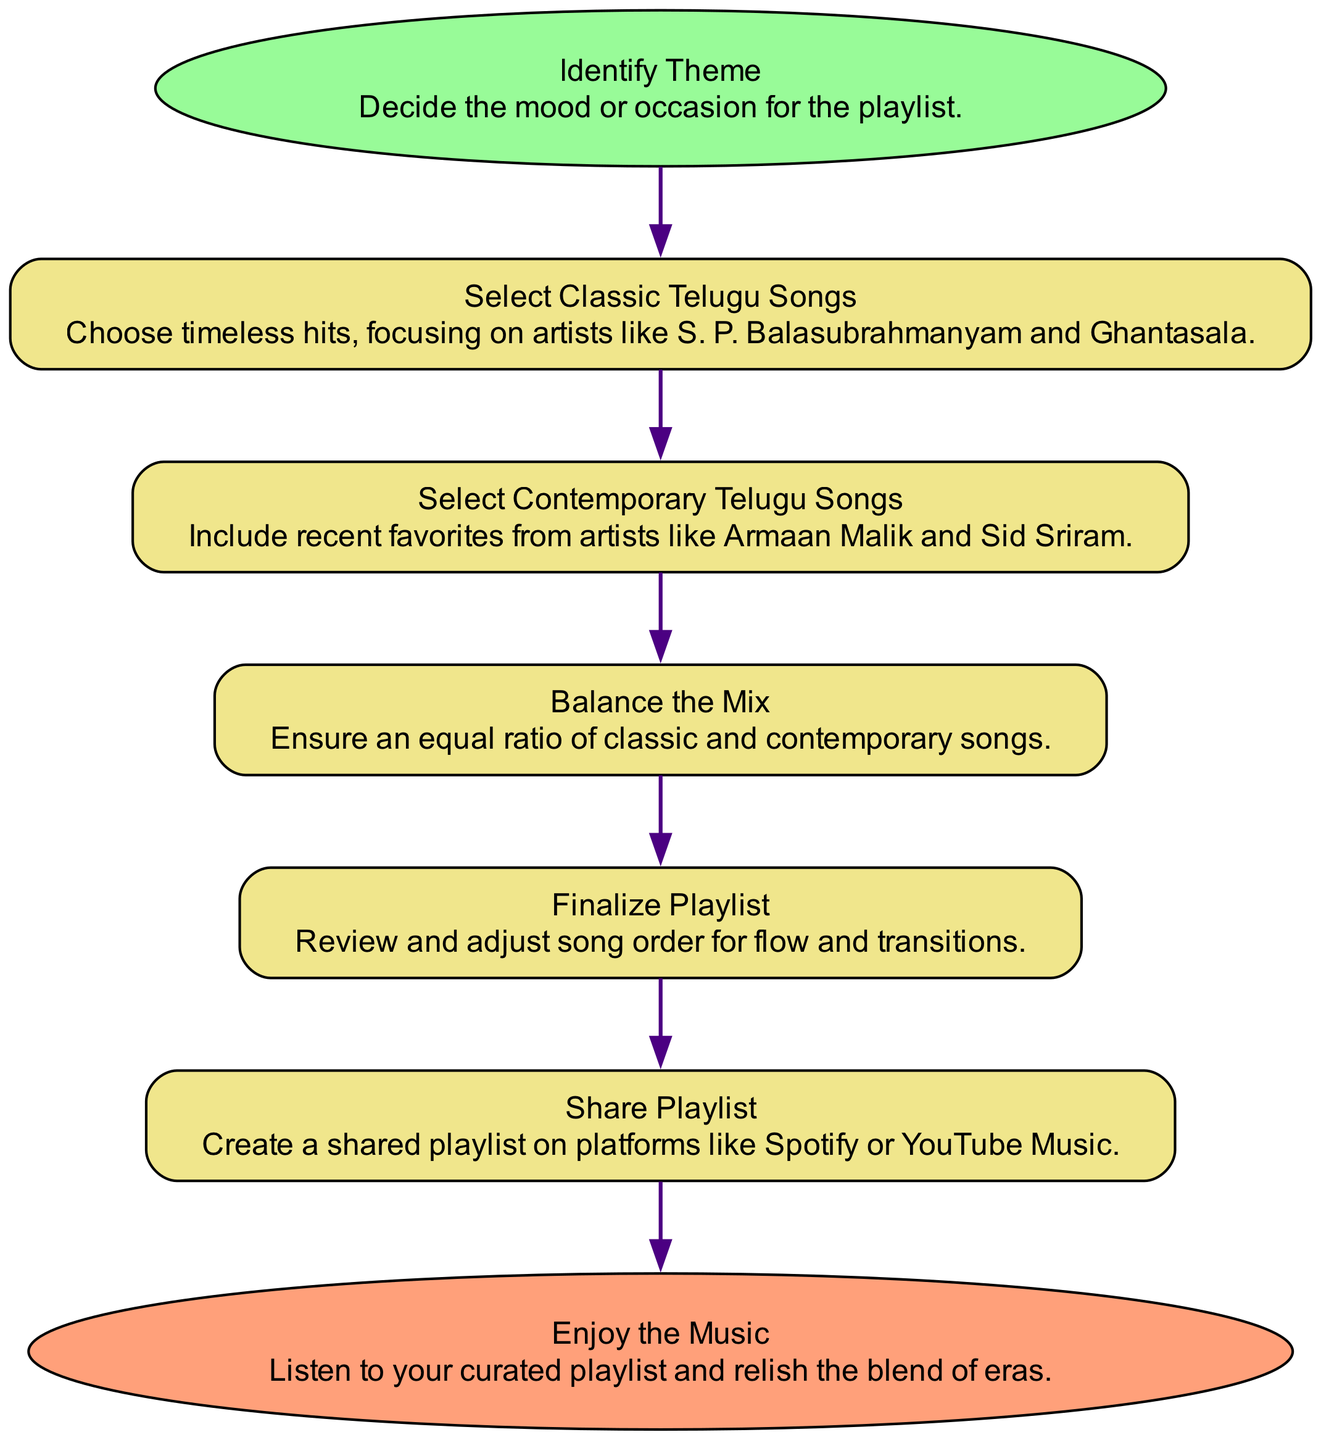What is the first step in the flow chart? The first node in the diagram is labeled "Identify Theme," which is the starting point for creating the playlist.
Answer: Identify Theme Which artist is mentioned in the classic selection step? The classic selection step specifically highlights artists like S. P. Balasubrahmanyam and Ghantasala as examples of timeless hits to include.
Answer: S. P. Balasubrahmanyam What is the purpose of the "Balance the Mix" step? This step ensures that the playlist contains an equal ratio of classic and contemporary songs, maintaining a balanced listening experience.
Answer: Ensure an equal ratio How many nodes are there in the flow chart? Counting each unique step including start and end nodes, there are a total of six nodes in the flow chart.
Answer: Six What comes after "Select Classic Telugu Songs"? The next step in the flow chart after "Select Classic Telugu Songs" is "Select Contemporary Telugu Songs," indicating a progression in creating the playlist.
Answer: Select Contemporary Telugu Songs What is the last step depicted in the flow chart? The final step is labeled "Enjoy the Music," which indicates the conclusion of the playlist creation process where one listens to the finished playlist.
Answer: Enjoy the Music What color is used for the "start" node in the diagram? The "start" node is colored light green, specifically indicated as #98FB98 in the flow chart's color scheme.
Answer: Light green How many edges connect the nodes in the flow chart? Each step connects to the next one sequentially, leading to a total of five edges in the flow chart connecting the six nodes.
Answer: Five Which step involves sharing the playlist? The step titled "Share Playlist" specifically involves creating a shared playlist on platforms like Spotify or YouTube Music.
Answer: Share Playlist 